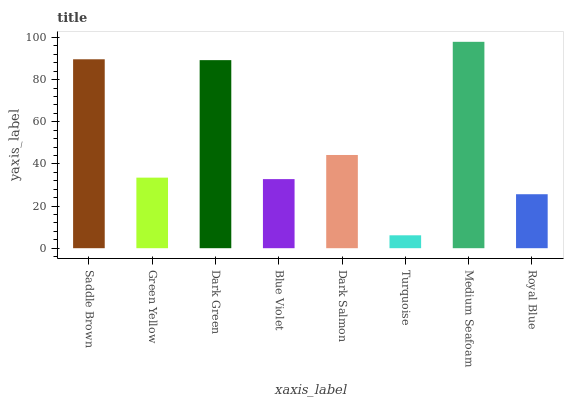Is Turquoise the minimum?
Answer yes or no. Yes. Is Medium Seafoam the maximum?
Answer yes or no. Yes. Is Green Yellow the minimum?
Answer yes or no. No. Is Green Yellow the maximum?
Answer yes or no. No. Is Saddle Brown greater than Green Yellow?
Answer yes or no. Yes. Is Green Yellow less than Saddle Brown?
Answer yes or no. Yes. Is Green Yellow greater than Saddle Brown?
Answer yes or no. No. Is Saddle Brown less than Green Yellow?
Answer yes or no. No. Is Dark Salmon the high median?
Answer yes or no. Yes. Is Green Yellow the low median?
Answer yes or no. Yes. Is Dark Green the high median?
Answer yes or no. No. Is Saddle Brown the low median?
Answer yes or no. No. 